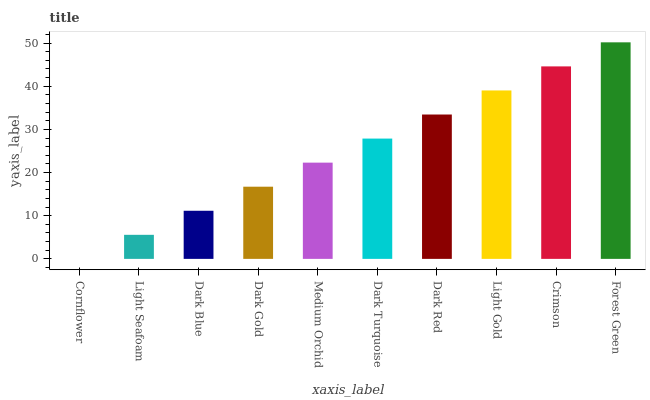Is Light Seafoam the minimum?
Answer yes or no. No. Is Light Seafoam the maximum?
Answer yes or no. No. Is Light Seafoam greater than Cornflower?
Answer yes or no. Yes. Is Cornflower less than Light Seafoam?
Answer yes or no. Yes. Is Cornflower greater than Light Seafoam?
Answer yes or no. No. Is Light Seafoam less than Cornflower?
Answer yes or no. No. Is Dark Turquoise the high median?
Answer yes or no. Yes. Is Medium Orchid the low median?
Answer yes or no. Yes. Is Dark Blue the high median?
Answer yes or no. No. Is Cornflower the low median?
Answer yes or no. No. 